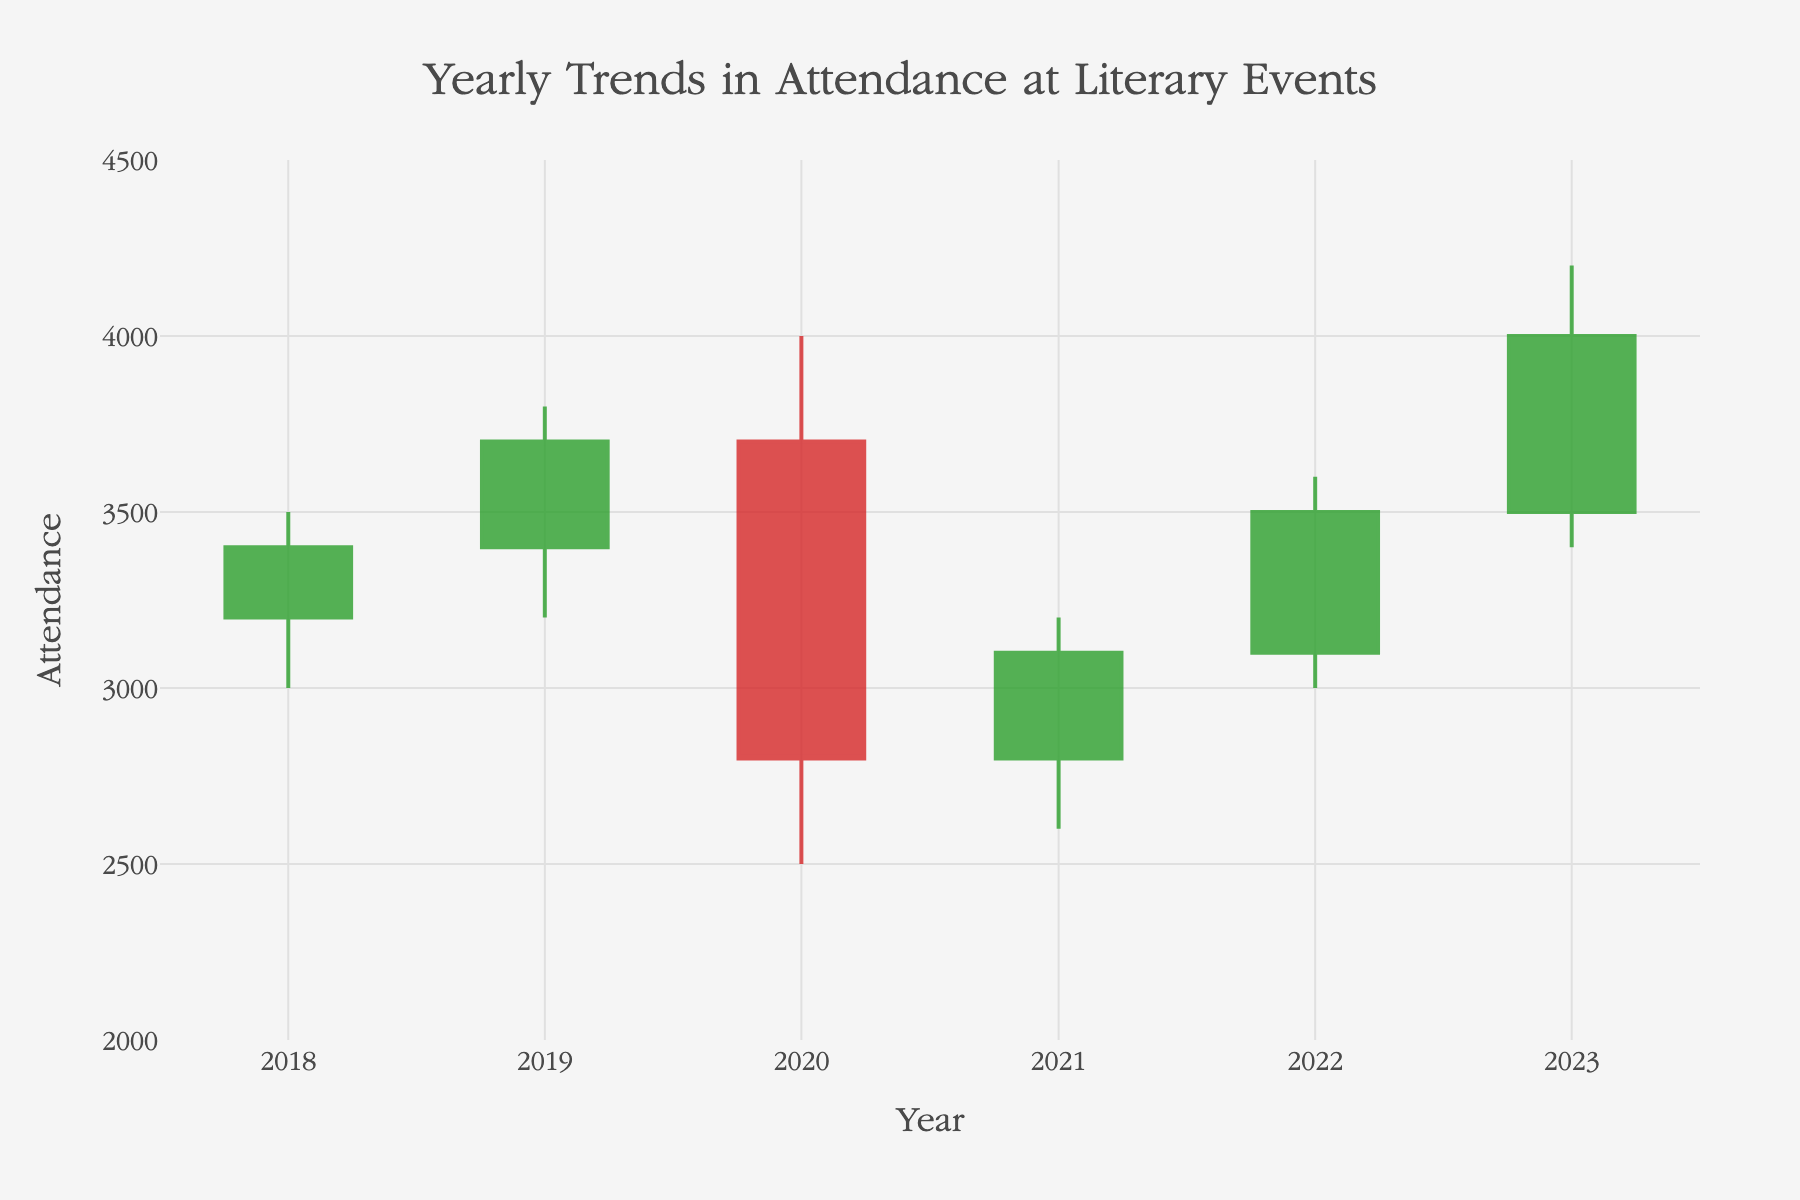What is the title of the chart? The title of the chart is located at the top and is clearly visible. It reads "Yearly Trends in Attendance at Literary Events".
Answer: Yearly Trends in Attendance at Literary Events How many years of data are displayed in the chart? The x-axis of the chart shows the distribution of data points based on years, showing one data point for each year from 2018 to 2023.
Answer: 6 In which year did the lowest attendance occur? To identify the year with the lowest attendance, look for the lowest point on the chart's y-axis across all bars. The lowest point is in 2020, where the Low value is 2500.
Answer: 2020 Which year recorded the highest peak attendance? To determine the year with the highest peak attendance, check the High values of each year's candlestick. The highest peak attendance was in 2023, where the High value is 4200.
Answer: 2023 By how much did attendance increase from the opening in 2018 to the closing in 2023? The opening attendance in 2018 is 3200, and the closing attendance in 2023 is 4000. The increase in attendance is 4000 - 3200 = 800.
Answer: 800 What was the attendance range (difference between high and low) in 2019? The High and Low values for 2019 can be found on the candlestick. The range is calculated as 3800 (High) - 3200 (Low) = 600.
Answer: 600 How does the closing attendance in 2018 compare to the closing attendance in 2021? The closing attendance in 2018 was 3400, and in 2021, it was 3100. The comparison indicates that the attendance was higher in 2018 by 300.
Answer: Higher by 300 Which year saw the greatest difference between its High and Low attendance values? Calculate the difference between the High and Low values for each year and compare them. The differences are as follows: 2018 (500), 2019 (600), 2020 (1500), 2021 (600), 2022 (600), and 2023 (800). The greatest difference occurred in 2020.
Answer: 2020 What was the attendance trend between 2020 and 2021? Analyzing the closing values, there was an increase from 2800 in 2020 to 3100 in 2021, indicating an upward trend in attendance.
Answer: Upward trend from 2800 to 3100 Which years experienced a closing attendance greater than their respective opening attendance? Compare the opening and closing values for each year. The years 2018 (3400 > 3200), 2019 (3700 > 3400), 2022 (3500 > 3100), and 2023 (4000 > 3500) experienced higher closing attendances than their openings.
Answer: 2018, 2019, 2022, 2023 